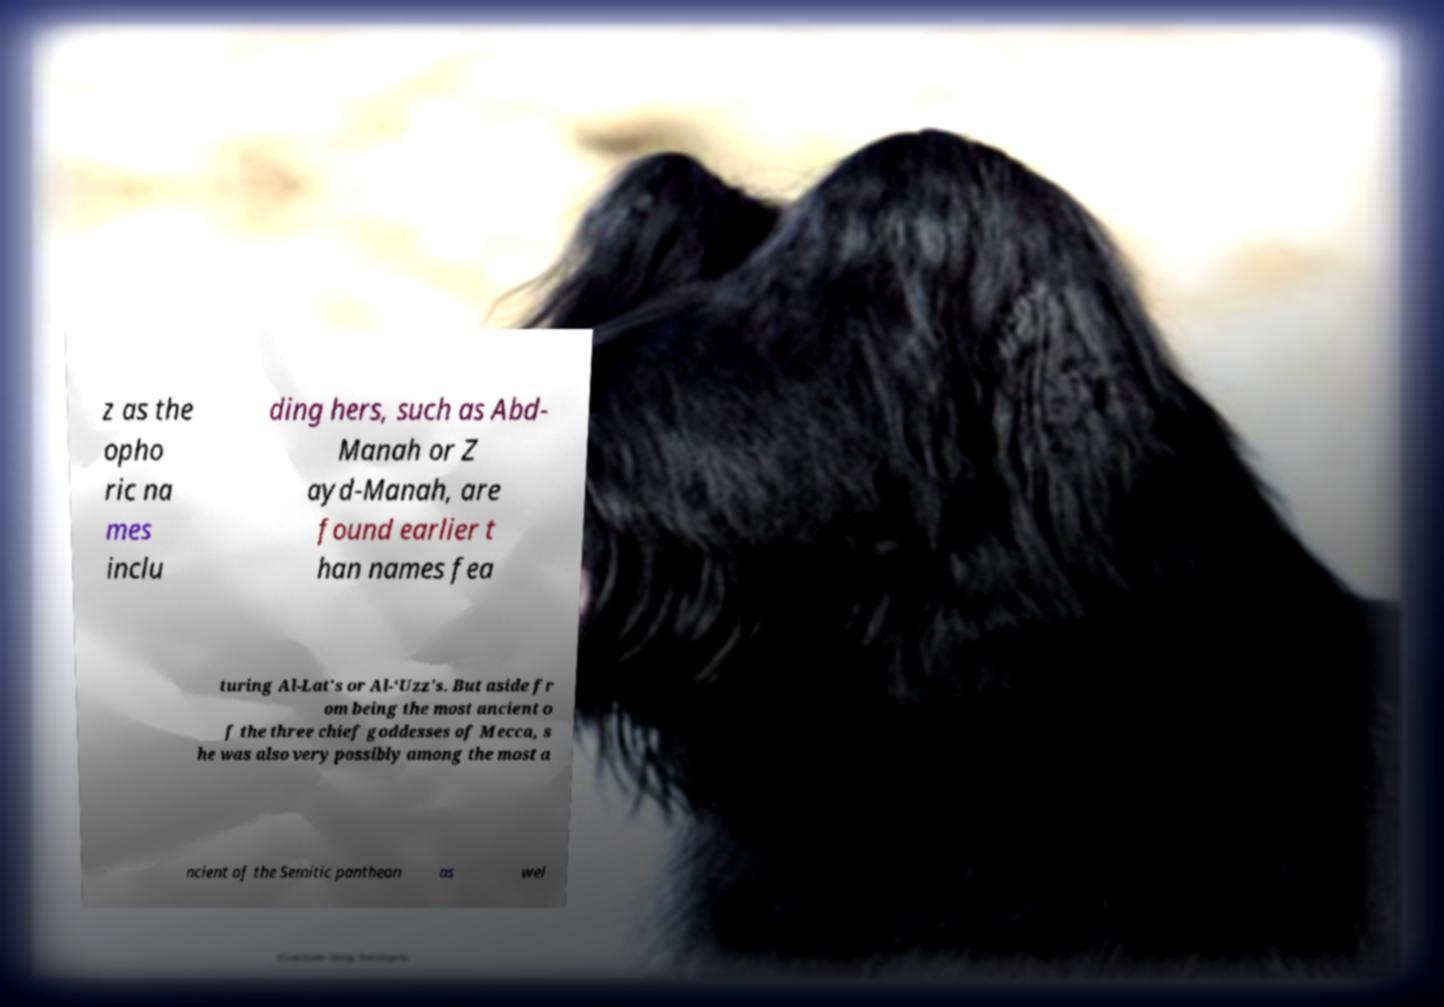Can you read and provide the text displayed in the image?This photo seems to have some interesting text. Can you extract and type it out for me? z as the opho ric na mes inclu ding hers, such as Abd- Manah or Z ayd-Manah, are found earlier t han names fea turing Al-Lat's or Al-‘Uzz's. But aside fr om being the most ancient o f the three chief goddesses of Mecca, s he was also very possibly among the most a ncient of the Semitic pantheon as wel 